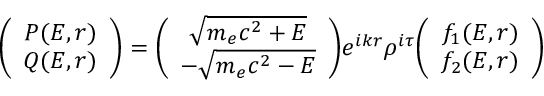Convert formula to latex. <formula><loc_0><loc_0><loc_500><loc_500>\left ( \begin{array} { c c } { P ( E , r ) } \\ { Q ( E , r ) } \end{array} \right ) = \left ( \begin{array} { c c } { \sqrt { m _ { e } c ^ { 2 } + E } } \\ { - \sqrt { m _ { e } c ^ { 2 } - E } } \end{array} \right ) e ^ { i k r } \rho ^ { i \tau } \left ( \begin{array} { c c } { f _ { 1 } ( E , r ) } \\ { f _ { 2 } ( E , r ) } \end{array} \right )</formula> 